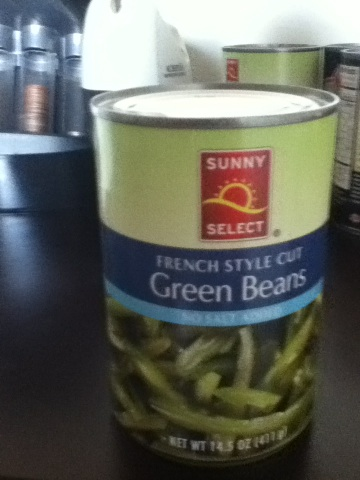Are French style green beans different from regular cut green beans? Yes, French style green beans are typically thinner and more tender than regular cut green beans because they are sliced lengthwise. This can influence not only the texture but also the cooking time, often being quicker to prepare than the regular cut. 